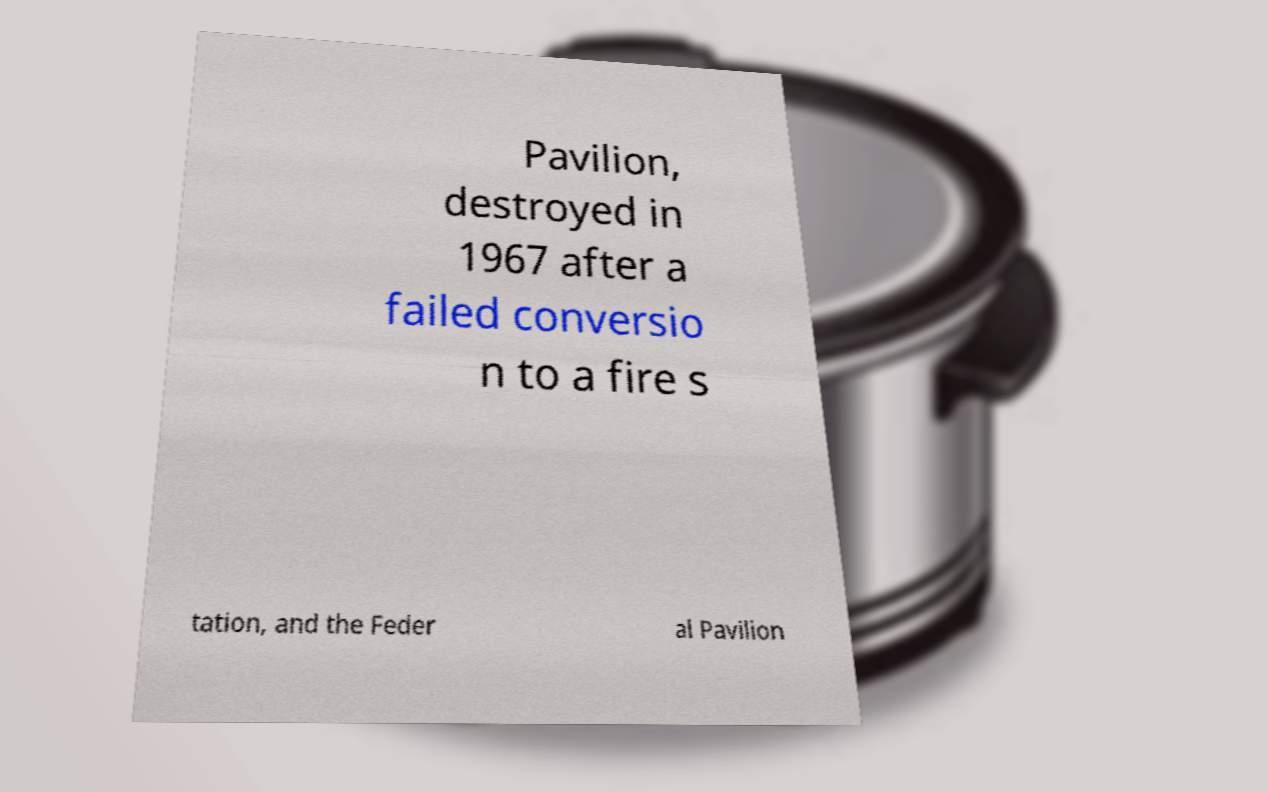Could you extract and type out the text from this image? Pavilion, destroyed in 1967 after a failed conversio n to a fire s tation, and the Feder al Pavilion 